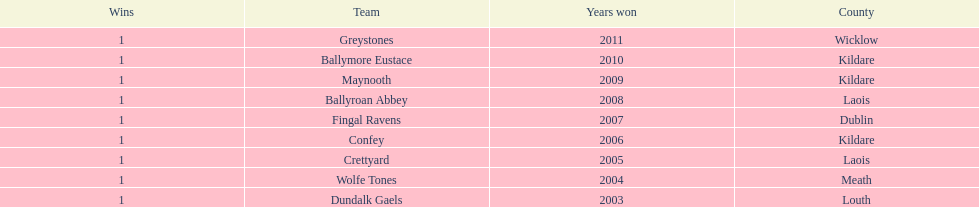Ballymore eustace is from the same county as what team that won in 2009? Maynooth. 